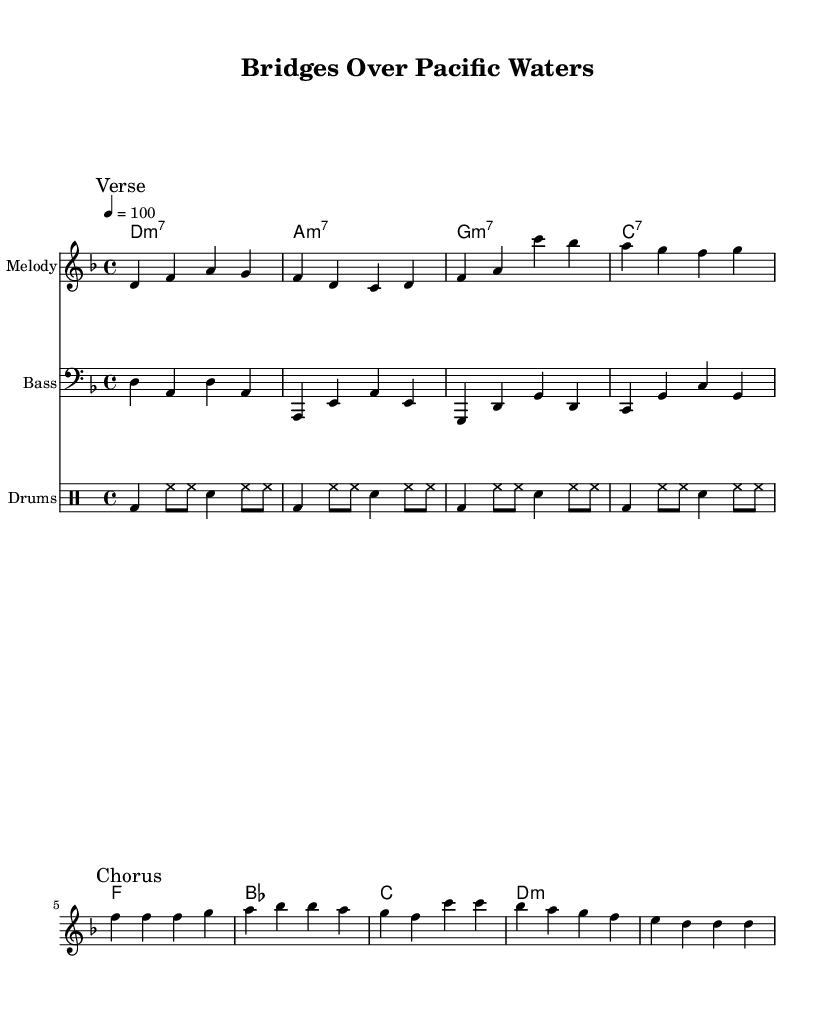What is the key signature of this music? The key signature is D minor, which has one flat (B flat). Looking at the key signature indicated at the beginning of the music, we see a flat sign on the B line, confirming that it is in D minor.
Answer: D minor What is the time signature of this music? The time signature is 4/4, indicated at the beginning of the sheet music. This means there are four beats in each measure, and a quarter note gets one beat.
Answer: 4/4 What is the tempo marking for this piece? The tempo marking is 100 beats per minute, indicated by the number 4 = 100 above the staff. This specifies how quickly the piece should be played.
Answer: 100 How many measures are in the melody section? There are eight measures in the melody section as indicated by the layout of the notes in the music. Each group of notes separated by vertical bars represents a measure.
Answer: 8 What is the first chord in the piece? The first chord is D minor 7, derived from the chord names written above the melody. It corresponds to the first measure of the music, indicating the harmony played.
Answer: D minor 7 What instrumentation is indicated for the melody? The melody is indicated for a staff labeled "Melody," showing its role in the composition. There are no specific instrument names mentioned but the staff is designated for melodic lines.
Answer: Melody What is the function of the drum part in this song? The drum part provides a rhythmic foundation and complements the overall groove typical of funk music. The pattern consists of bass drum (bd), hi-hat (hh), and snare (sn) hits, creating a lively beat characteristic of the genre.
Answer: Rhythmic foundation 